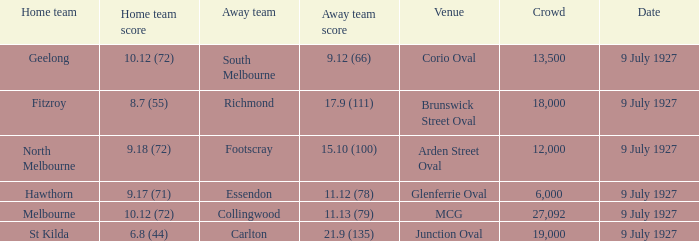How big was the crowd when the away team was Richmond? 18000.0. 